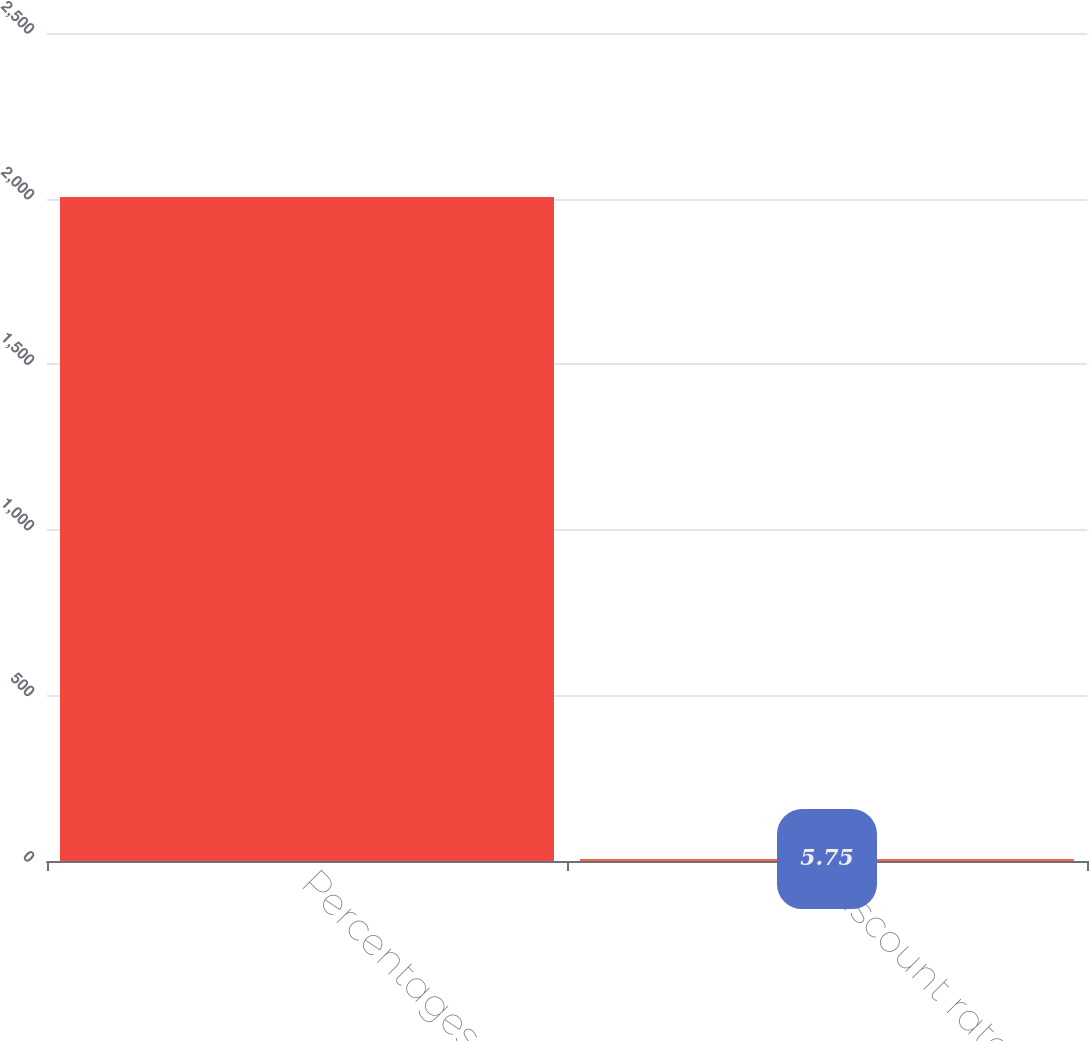Convert chart to OTSL. <chart><loc_0><loc_0><loc_500><loc_500><bar_chart><fcel>Percentages<fcel>Discount rate<nl><fcel>2005<fcel>5.75<nl></chart> 